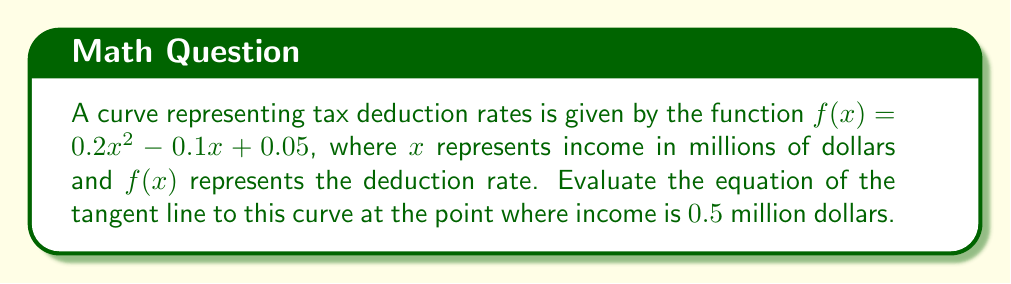Provide a solution to this math problem. To find the equation of the tangent line, we need to follow these steps:

1. Find the point of tangency:
   - $x = 0.5$ (given in the question)
   - $y = f(0.5) = 0.2(0.5)^2 - 0.1(0.5) + 0.05 = 0.05 - 0.05 + 0.05 = 0.05$
   - The point of tangency is $(0.5, 0.05)$

2. Calculate the derivative of $f(x)$:
   $f'(x) = 0.4x - 0.1$

3. Evaluate the derivative at $x = 0.5$:
   $f'(0.5) = 0.4(0.5) - 0.1 = 0.2 - 0.1 = 0.1$

4. Use the point-slope form of a line:
   $y - y_1 = m(x - x_1)$, where $(x_1, y_1)$ is the point of tangency and $m$ is the slope

5. Substitute the values:
   $y - 0.05 = 0.1(x - 0.5)$

6. Simplify to get the equation of the tangent line:
   $y = 0.1x - 0.05 + 0.05$
   $y = 0.1x$

Therefore, the equation of the tangent line is $y = 0.1x$.
Answer: $y = 0.1x$ 